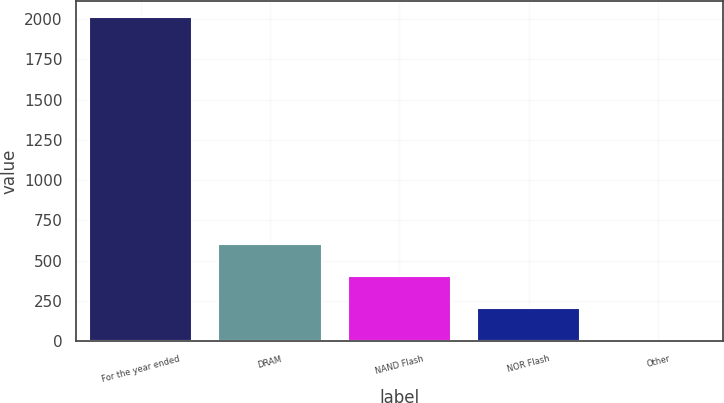Convert chart to OTSL. <chart><loc_0><loc_0><loc_500><loc_500><bar_chart><fcel>For the year ended<fcel>DRAM<fcel>NAND Flash<fcel>NOR Flash<fcel>Other<nl><fcel>2014<fcel>605.6<fcel>404.4<fcel>203.2<fcel>2<nl></chart> 